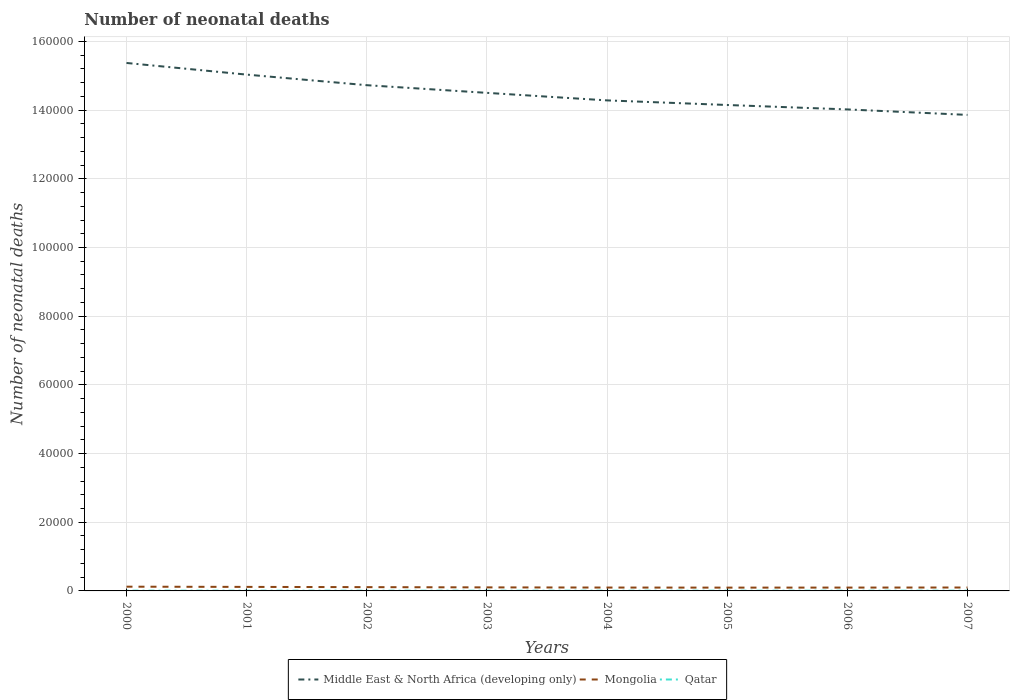How many different coloured lines are there?
Ensure brevity in your answer.  3. Does the line corresponding to Mongolia intersect with the line corresponding to Middle East & North Africa (developing only)?
Provide a succinct answer. No. Is the number of lines equal to the number of legend labels?
Your response must be concise. Yes. Across all years, what is the maximum number of neonatal deaths in in Mongolia?
Ensure brevity in your answer.  962. In which year was the number of neonatal deaths in in Qatar maximum?
Give a very brief answer. 2003. What is the total number of neonatal deaths in in Middle East & North Africa (developing only) in the graph?
Keep it short and to the point. 5764. What is the difference between the highest and the second highest number of neonatal deaths in in Qatar?
Provide a short and direct response. 11. What is the difference between the highest and the lowest number of neonatal deaths in in Qatar?
Keep it short and to the point. 2. Is the number of neonatal deaths in in Qatar strictly greater than the number of neonatal deaths in in Mongolia over the years?
Offer a very short reply. Yes. How many lines are there?
Give a very brief answer. 3. How many years are there in the graph?
Provide a short and direct response. 8. What is the difference between two consecutive major ticks on the Y-axis?
Your answer should be compact. 2.00e+04. Does the graph contain any zero values?
Provide a short and direct response. No. Does the graph contain grids?
Keep it short and to the point. Yes. Where does the legend appear in the graph?
Your response must be concise. Bottom center. How many legend labels are there?
Give a very brief answer. 3. What is the title of the graph?
Your answer should be compact. Number of neonatal deaths. Does "Kosovo" appear as one of the legend labels in the graph?
Give a very brief answer. No. What is the label or title of the X-axis?
Ensure brevity in your answer.  Years. What is the label or title of the Y-axis?
Your response must be concise. Number of neonatal deaths. What is the Number of neonatal deaths in Middle East & North Africa (developing only) in 2000?
Provide a short and direct response. 1.54e+05. What is the Number of neonatal deaths in Mongolia in 2000?
Your answer should be very brief. 1234. What is the Number of neonatal deaths of Middle East & North Africa (developing only) in 2001?
Offer a very short reply. 1.50e+05. What is the Number of neonatal deaths in Mongolia in 2001?
Your answer should be compact. 1172. What is the Number of neonatal deaths in Qatar in 2001?
Offer a terse response. 73. What is the Number of neonatal deaths in Middle East & North Africa (developing only) in 2002?
Offer a terse response. 1.47e+05. What is the Number of neonatal deaths of Mongolia in 2002?
Offer a very short reply. 1103. What is the Number of neonatal deaths in Qatar in 2002?
Provide a succinct answer. 70. What is the Number of neonatal deaths in Middle East & North Africa (developing only) in 2003?
Ensure brevity in your answer.  1.45e+05. What is the Number of neonatal deaths in Mongolia in 2003?
Keep it short and to the point. 1032. What is the Number of neonatal deaths in Middle East & North Africa (developing only) in 2004?
Provide a succinct answer. 1.43e+05. What is the Number of neonatal deaths of Mongolia in 2004?
Your answer should be compact. 984. What is the Number of neonatal deaths of Qatar in 2004?
Keep it short and to the point. 67. What is the Number of neonatal deaths of Middle East & North Africa (developing only) in 2005?
Your response must be concise. 1.41e+05. What is the Number of neonatal deaths in Mongolia in 2005?
Your response must be concise. 962. What is the Number of neonatal deaths of Qatar in 2005?
Your answer should be compact. 70. What is the Number of neonatal deaths in Middle East & North Africa (developing only) in 2006?
Provide a short and direct response. 1.40e+05. What is the Number of neonatal deaths in Mongolia in 2006?
Offer a terse response. 974. What is the Number of neonatal deaths of Middle East & North Africa (developing only) in 2007?
Make the answer very short. 1.39e+05. What is the Number of neonatal deaths of Mongolia in 2007?
Offer a very short reply. 995. What is the Number of neonatal deaths of Qatar in 2007?
Provide a succinct answer. 69. Across all years, what is the maximum Number of neonatal deaths in Middle East & North Africa (developing only)?
Your answer should be compact. 1.54e+05. Across all years, what is the maximum Number of neonatal deaths of Mongolia?
Your response must be concise. 1234. Across all years, what is the maximum Number of neonatal deaths of Qatar?
Provide a succinct answer. 78. Across all years, what is the minimum Number of neonatal deaths of Middle East & North Africa (developing only)?
Your answer should be compact. 1.39e+05. Across all years, what is the minimum Number of neonatal deaths of Mongolia?
Provide a short and direct response. 962. What is the total Number of neonatal deaths of Middle East & North Africa (developing only) in the graph?
Your answer should be very brief. 1.16e+06. What is the total Number of neonatal deaths of Mongolia in the graph?
Provide a succinct answer. 8456. What is the total Number of neonatal deaths of Qatar in the graph?
Provide a short and direct response. 562. What is the difference between the Number of neonatal deaths of Middle East & North Africa (developing only) in 2000 and that in 2001?
Offer a terse response. 3390. What is the difference between the Number of neonatal deaths in Mongolia in 2000 and that in 2001?
Make the answer very short. 62. What is the difference between the Number of neonatal deaths of Qatar in 2000 and that in 2001?
Your answer should be very brief. 5. What is the difference between the Number of neonatal deaths in Middle East & North Africa (developing only) in 2000 and that in 2002?
Make the answer very short. 6473. What is the difference between the Number of neonatal deaths in Mongolia in 2000 and that in 2002?
Your answer should be very brief. 131. What is the difference between the Number of neonatal deaths of Qatar in 2000 and that in 2002?
Make the answer very short. 8. What is the difference between the Number of neonatal deaths of Middle East & North Africa (developing only) in 2000 and that in 2003?
Offer a very short reply. 8705. What is the difference between the Number of neonatal deaths in Mongolia in 2000 and that in 2003?
Your response must be concise. 202. What is the difference between the Number of neonatal deaths of Qatar in 2000 and that in 2003?
Your answer should be very brief. 11. What is the difference between the Number of neonatal deaths of Middle East & North Africa (developing only) in 2000 and that in 2004?
Keep it short and to the point. 1.09e+04. What is the difference between the Number of neonatal deaths of Mongolia in 2000 and that in 2004?
Make the answer very short. 250. What is the difference between the Number of neonatal deaths of Middle East & North Africa (developing only) in 2000 and that in 2005?
Your response must be concise. 1.22e+04. What is the difference between the Number of neonatal deaths in Mongolia in 2000 and that in 2005?
Your answer should be compact. 272. What is the difference between the Number of neonatal deaths of Qatar in 2000 and that in 2005?
Make the answer very short. 8. What is the difference between the Number of neonatal deaths of Middle East & North Africa (developing only) in 2000 and that in 2006?
Your answer should be compact. 1.35e+04. What is the difference between the Number of neonatal deaths of Mongolia in 2000 and that in 2006?
Offer a terse response. 260. What is the difference between the Number of neonatal deaths of Middle East & North Africa (developing only) in 2000 and that in 2007?
Your answer should be very brief. 1.51e+04. What is the difference between the Number of neonatal deaths of Mongolia in 2000 and that in 2007?
Provide a succinct answer. 239. What is the difference between the Number of neonatal deaths of Middle East & North Africa (developing only) in 2001 and that in 2002?
Provide a short and direct response. 3083. What is the difference between the Number of neonatal deaths of Mongolia in 2001 and that in 2002?
Your answer should be very brief. 69. What is the difference between the Number of neonatal deaths in Middle East & North Africa (developing only) in 2001 and that in 2003?
Offer a terse response. 5315. What is the difference between the Number of neonatal deaths of Mongolia in 2001 and that in 2003?
Offer a terse response. 140. What is the difference between the Number of neonatal deaths of Qatar in 2001 and that in 2003?
Provide a short and direct response. 6. What is the difference between the Number of neonatal deaths of Middle East & North Africa (developing only) in 2001 and that in 2004?
Your answer should be compact. 7510. What is the difference between the Number of neonatal deaths of Mongolia in 2001 and that in 2004?
Provide a succinct answer. 188. What is the difference between the Number of neonatal deaths of Middle East & North Africa (developing only) in 2001 and that in 2005?
Your answer should be very brief. 8847. What is the difference between the Number of neonatal deaths in Mongolia in 2001 and that in 2005?
Provide a short and direct response. 210. What is the difference between the Number of neonatal deaths in Qatar in 2001 and that in 2005?
Offer a very short reply. 3. What is the difference between the Number of neonatal deaths in Middle East & North Africa (developing only) in 2001 and that in 2006?
Provide a short and direct response. 1.01e+04. What is the difference between the Number of neonatal deaths of Mongolia in 2001 and that in 2006?
Offer a terse response. 198. What is the difference between the Number of neonatal deaths in Qatar in 2001 and that in 2006?
Make the answer very short. 5. What is the difference between the Number of neonatal deaths in Middle East & North Africa (developing only) in 2001 and that in 2007?
Make the answer very short. 1.17e+04. What is the difference between the Number of neonatal deaths in Mongolia in 2001 and that in 2007?
Keep it short and to the point. 177. What is the difference between the Number of neonatal deaths of Qatar in 2001 and that in 2007?
Give a very brief answer. 4. What is the difference between the Number of neonatal deaths of Middle East & North Africa (developing only) in 2002 and that in 2003?
Offer a very short reply. 2232. What is the difference between the Number of neonatal deaths in Mongolia in 2002 and that in 2003?
Give a very brief answer. 71. What is the difference between the Number of neonatal deaths of Middle East & North Africa (developing only) in 2002 and that in 2004?
Give a very brief answer. 4427. What is the difference between the Number of neonatal deaths of Mongolia in 2002 and that in 2004?
Ensure brevity in your answer.  119. What is the difference between the Number of neonatal deaths of Middle East & North Africa (developing only) in 2002 and that in 2005?
Offer a very short reply. 5764. What is the difference between the Number of neonatal deaths of Mongolia in 2002 and that in 2005?
Offer a very short reply. 141. What is the difference between the Number of neonatal deaths in Qatar in 2002 and that in 2005?
Offer a terse response. 0. What is the difference between the Number of neonatal deaths of Middle East & North Africa (developing only) in 2002 and that in 2006?
Your response must be concise. 7053. What is the difference between the Number of neonatal deaths of Mongolia in 2002 and that in 2006?
Your answer should be compact. 129. What is the difference between the Number of neonatal deaths of Middle East & North Africa (developing only) in 2002 and that in 2007?
Give a very brief answer. 8648. What is the difference between the Number of neonatal deaths of Mongolia in 2002 and that in 2007?
Ensure brevity in your answer.  108. What is the difference between the Number of neonatal deaths in Qatar in 2002 and that in 2007?
Make the answer very short. 1. What is the difference between the Number of neonatal deaths in Middle East & North Africa (developing only) in 2003 and that in 2004?
Make the answer very short. 2195. What is the difference between the Number of neonatal deaths in Mongolia in 2003 and that in 2004?
Offer a very short reply. 48. What is the difference between the Number of neonatal deaths of Middle East & North Africa (developing only) in 2003 and that in 2005?
Provide a succinct answer. 3532. What is the difference between the Number of neonatal deaths of Mongolia in 2003 and that in 2005?
Your response must be concise. 70. What is the difference between the Number of neonatal deaths in Qatar in 2003 and that in 2005?
Your answer should be very brief. -3. What is the difference between the Number of neonatal deaths in Middle East & North Africa (developing only) in 2003 and that in 2006?
Ensure brevity in your answer.  4821. What is the difference between the Number of neonatal deaths of Qatar in 2003 and that in 2006?
Provide a short and direct response. -1. What is the difference between the Number of neonatal deaths in Middle East & North Africa (developing only) in 2003 and that in 2007?
Your answer should be compact. 6416. What is the difference between the Number of neonatal deaths in Qatar in 2003 and that in 2007?
Give a very brief answer. -2. What is the difference between the Number of neonatal deaths in Middle East & North Africa (developing only) in 2004 and that in 2005?
Provide a short and direct response. 1337. What is the difference between the Number of neonatal deaths of Mongolia in 2004 and that in 2005?
Your answer should be compact. 22. What is the difference between the Number of neonatal deaths of Middle East & North Africa (developing only) in 2004 and that in 2006?
Your answer should be compact. 2626. What is the difference between the Number of neonatal deaths of Qatar in 2004 and that in 2006?
Ensure brevity in your answer.  -1. What is the difference between the Number of neonatal deaths of Middle East & North Africa (developing only) in 2004 and that in 2007?
Offer a very short reply. 4221. What is the difference between the Number of neonatal deaths in Middle East & North Africa (developing only) in 2005 and that in 2006?
Provide a succinct answer. 1289. What is the difference between the Number of neonatal deaths in Qatar in 2005 and that in 2006?
Give a very brief answer. 2. What is the difference between the Number of neonatal deaths of Middle East & North Africa (developing only) in 2005 and that in 2007?
Offer a very short reply. 2884. What is the difference between the Number of neonatal deaths in Mongolia in 2005 and that in 2007?
Your answer should be very brief. -33. What is the difference between the Number of neonatal deaths of Middle East & North Africa (developing only) in 2006 and that in 2007?
Offer a very short reply. 1595. What is the difference between the Number of neonatal deaths of Qatar in 2006 and that in 2007?
Your response must be concise. -1. What is the difference between the Number of neonatal deaths of Middle East & North Africa (developing only) in 2000 and the Number of neonatal deaths of Mongolia in 2001?
Your answer should be compact. 1.53e+05. What is the difference between the Number of neonatal deaths of Middle East & North Africa (developing only) in 2000 and the Number of neonatal deaths of Qatar in 2001?
Give a very brief answer. 1.54e+05. What is the difference between the Number of neonatal deaths in Mongolia in 2000 and the Number of neonatal deaths in Qatar in 2001?
Give a very brief answer. 1161. What is the difference between the Number of neonatal deaths in Middle East & North Africa (developing only) in 2000 and the Number of neonatal deaths in Mongolia in 2002?
Offer a terse response. 1.53e+05. What is the difference between the Number of neonatal deaths of Middle East & North Africa (developing only) in 2000 and the Number of neonatal deaths of Qatar in 2002?
Your response must be concise. 1.54e+05. What is the difference between the Number of neonatal deaths in Mongolia in 2000 and the Number of neonatal deaths in Qatar in 2002?
Keep it short and to the point. 1164. What is the difference between the Number of neonatal deaths in Middle East & North Africa (developing only) in 2000 and the Number of neonatal deaths in Mongolia in 2003?
Ensure brevity in your answer.  1.53e+05. What is the difference between the Number of neonatal deaths in Middle East & North Africa (developing only) in 2000 and the Number of neonatal deaths in Qatar in 2003?
Provide a succinct answer. 1.54e+05. What is the difference between the Number of neonatal deaths in Mongolia in 2000 and the Number of neonatal deaths in Qatar in 2003?
Provide a short and direct response. 1167. What is the difference between the Number of neonatal deaths of Middle East & North Africa (developing only) in 2000 and the Number of neonatal deaths of Mongolia in 2004?
Provide a short and direct response. 1.53e+05. What is the difference between the Number of neonatal deaths of Middle East & North Africa (developing only) in 2000 and the Number of neonatal deaths of Qatar in 2004?
Provide a succinct answer. 1.54e+05. What is the difference between the Number of neonatal deaths of Mongolia in 2000 and the Number of neonatal deaths of Qatar in 2004?
Offer a very short reply. 1167. What is the difference between the Number of neonatal deaths in Middle East & North Africa (developing only) in 2000 and the Number of neonatal deaths in Mongolia in 2005?
Your answer should be compact. 1.53e+05. What is the difference between the Number of neonatal deaths in Middle East & North Africa (developing only) in 2000 and the Number of neonatal deaths in Qatar in 2005?
Keep it short and to the point. 1.54e+05. What is the difference between the Number of neonatal deaths in Mongolia in 2000 and the Number of neonatal deaths in Qatar in 2005?
Give a very brief answer. 1164. What is the difference between the Number of neonatal deaths in Middle East & North Africa (developing only) in 2000 and the Number of neonatal deaths in Mongolia in 2006?
Your response must be concise. 1.53e+05. What is the difference between the Number of neonatal deaths in Middle East & North Africa (developing only) in 2000 and the Number of neonatal deaths in Qatar in 2006?
Provide a short and direct response. 1.54e+05. What is the difference between the Number of neonatal deaths of Mongolia in 2000 and the Number of neonatal deaths of Qatar in 2006?
Offer a very short reply. 1166. What is the difference between the Number of neonatal deaths in Middle East & North Africa (developing only) in 2000 and the Number of neonatal deaths in Mongolia in 2007?
Give a very brief answer. 1.53e+05. What is the difference between the Number of neonatal deaths of Middle East & North Africa (developing only) in 2000 and the Number of neonatal deaths of Qatar in 2007?
Keep it short and to the point. 1.54e+05. What is the difference between the Number of neonatal deaths of Mongolia in 2000 and the Number of neonatal deaths of Qatar in 2007?
Keep it short and to the point. 1165. What is the difference between the Number of neonatal deaths of Middle East & North Africa (developing only) in 2001 and the Number of neonatal deaths of Mongolia in 2002?
Keep it short and to the point. 1.49e+05. What is the difference between the Number of neonatal deaths in Middle East & North Africa (developing only) in 2001 and the Number of neonatal deaths in Qatar in 2002?
Ensure brevity in your answer.  1.50e+05. What is the difference between the Number of neonatal deaths of Mongolia in 2001 and the Number of neonatal deaths of Qatar in 2002?
Offer a very short reply. 1102. What is the difference between the Number of neonatal deaths of Middle East & North Africa (developing only) in 2001 and the Number of neonatal deaths of Mongolia in 2003?
Provide a succinct answer. 1.49e+05. What is the difference between the Number of neonatal deaths of Middle East & North Africa (developing only) in 2001 and the Number of neonatal deaths of Qatar in 2003?
Your answer should be compact. 1.50e+05. What is the difference between the Number of neonatal deaths in Mongolia in 2001 and the Number of neonatal deaths in Qatar in 2003?
Make the answer very short. 1105. What is the difference between the Number of neonatal deaths of Middle East & North Africa (developing only) in 2001 and the Number of neonatal deaths of Mongolia in 2004?
Provide a succinct answer. 1.49e+05. What is the difference between the Number of neonatal deaths of Middle East & North Africa (developing only) in 2001 and the Number of neonatal deaths of Qatar in 2004?
Offer a terse response. 1.50e+05. What is the difference between the Number of neonatal deaths of Mongolia in 2001 and the Number of neonatal deaths of Qatar in 2004?
Provide a succinct answer. 1105. What is the difference between the Number of neonatal deaths of Middle East & North Africa (developing only) in 2001 and the Number of neonatal deaths of Mongolia in 2005?
Keep it short and to the point. 1.49e+05. What is the difference between the Number of neonatal deaths of Middle East & North Africa (developing only) in 2001 and the Number of neonatal deaths of Qatar in 2005?
Give a very brief answer. 1.50e+05. What is the difference between the Number of neonatal deaths in Mongolia in 2001 and the Number of neonatal deaths in Qatar in 2005?
Give a very brief answer. 1102. What is the difference between the Number of neonatal deaths in Middle East & North Africa (developing only) in 2001 and the Number of neonatal deaths in Mongolia in 2006?
Provide a short and direct response. 1.49e+05. What is the difference between the Number of neonatal deaths of Middle East & North Africa (developing only) in 2001 and the Number of neonatal deaths of Qatar in 2006?
Provide a succinct answer. 1.50e+05. What is the difference between the Number of neonatal deaths of Mongolia in 2001 and the Number of neonatal deaths of Qatar in 2006?
Your answer should be compact. 1104. What is the difference between the Number of neonatal deaths of Middle East & North Africa (developing only) in 2001 and the Number of neonatal deaths of Mongolia in 2007?
Make the answer very short. 1.49e+05. What is the difference between the Number of neonatal deaths in Middle East & North Africa (developing only) in 2001 and the Number of neonatal deaths in Qatar in 2007?
Your answer should be compact. 1.50e+05. What is the difference between the Number of neonatal deaths in Mongolia in 2001 and the Number of neonatal deaths in Qatar in 2007?
Your answer should be compact. 1103. What is the difference between the Number of neonatal deaths of Middle East & North Africa (developing only) in 2002 and the Number of neonatal deaths of Mongolia in 2003?
Provide a short and direct response. 1.46e+05. What is the difference between the Number of neonatal deaths of Middle East & North Africa (developing only) in 2002 and the Number of neonatal deaths of Qatar in 2003?
Ensure brevity in your answer.  1.47e+05. What is the difference between the Number of neonatal deaths of Mongolia in 2002 and the Number of neonatal deaths of Qatar in 2003?
Ensure brevity in your answer.  1036. What is the difference between the Number of neonatal deaths of Middle East & North Africa (developing only) in 2002 and the Number of neonatal deaths of Mongolia in 2004?
Your response must be concise. 1.46e+05. What is the difference between the Number of neonatal deaths of Middle East & North Africa (developing only) in 2002 and the Number of neonatal deaths of Qatar in 2004?
Offer a very short reply. 1.47e+05. What is the difference between the Number of neonatal deaths of Mongolia in 2002 and the Number of neonatal deaths of Qatar in 2004?
Ensure brevity in your answer.  1036. What is the difference between the Number of neonatal deaths in Middle East & North Africa (developing only) in 2002 and the Number of neonatal deaths in Mongolia in 2005?
Make the answer very short. 1.46e+05. What is the difference between the Number of neonatal deaths in Middle East & North Africa (developing only) in 2002 and the Number of neonatal deaths in Qatar in 2005?
Give a very brief answer. 1.47e+05. What is the difference between the Number of neonatal deaths in Mongolia in 2002 and the Number of neonatal deaths in Qatar in 2005?
Offer a terse response. 1033. What is the difference between the Number of neonatal deaths of Middle East & North Africa (developing only) in 2002 and the Number of neonatal deaths of Mongolia in 2006?
Your response must be concise. 1.46e+05. What is the difference between the Number of neonatal deaths in Middle East & North Africa (developing only) in 2002 and the Number of neonatal deaths in Qatar in 2006?
Offer a very short reply. 1.47e+05. What is the difference between the Number of neonatal deaths in Mongolia in 2002 and the Number of neonatal deaths in Qatar in 2006?
Make the answer very short. 1035. What is the difference between the Number of neonatal deaths in Middle East & North Africa (developing only) in 2002 and the Number of neonatal deaths in Mongolia in 2007?
Your answer should be very brief. 1.46e+05. What is the difference between the Number of neonatal deaths of Middle East & North Africa (developing only) in 2002 and the Number of neonatal deaths of Qatar in 2007?
Provide a short and direct response. 1.47e+05. What is the difference between the Number of neonatal deaths in Mongolia in 2002 and the Number of neonatal deaths in Qatar in 2007?
Offer a very short reply. 1034. What is the difference between the Number of neonatal deaths in Middle East & North Africa (developing only) in 2003 and the Number of neonatal deaths in Mongolia in 2004?
Your response must be concise. 1.44e+05. What is the difference between the Number of neonatal deaths of Middle East & North Africa (developing only) in 2003 and the Number of neonatal deaths of Qatar in 2004?
Provide a succinct answer. 1.45e+05. What is the difference between the Number of neonatal deaths in Mongolia in 2003 and the Number of neonatal deaths in Qatar in 2004?
Your response must be concise. 965. What is the difference between the Number of neonatal deaths in Middle East & North Africa (developing only) in 2003 and the Number of neonatal deaths in Mongolia in 2005?
Your answer should be compact. 1.44e+05. What is the difference between the Number of neonatal deaths of Middle East & North Africa (developing only) in 2003 and the Number of neonatal deaths of Qatar in 2005?
Make the answer very short. 1.45e+05. What is the difference between the Number of neonatal deaths in Mongolia in 2003 and the Number of neonatal deaths in Qatar in 2005?
Provide a succinct answer. 962. What is the difference between the Number of neonatal deaths in Middle East & North Africa (developing only) in 2003 and the Number of neonatal deaths in Mongolia in 2006?
Keep it short and to the point. 1.44e+05. What is the difference between the Number of neonatal deaths of Middle East & North Africa (developing only) in 2003 and the Number of neonatal deaths of Qatar in 2006?
Offer a terse response. 1.45e+05. What is the difference between the Number of neonatal deaths of Mongolia in 2003 and the Number of neonatal deaths of Qatar in 2006?
Provide a short and direct response. 964. What is the difference between the Number of neonatal deaths in Middle East & North Africa (developing only) in 2003 and the Number of neonatal deaths in Mongolia in 2007?
Offer a terse response. 1.44e+05. What is the difference between the Number of neonatal deaths of Middle East & North Africa (developing only) in 2003 and the Number of neonatal deaths of Qatar in 2007?
Give a very brief answer. 1.45e+05. What is the difference between the Number of neonatal deaths of Mongolia in 2003 and the Number of neonatal deaths of Qatar in 2007?
Provide a short and direct response. 963. What is the difference between the Number of neonatal deaths in Middle East & North Africa (developing only) in 2004 and the Number of neonatal deaths in Mongolia in 2005?
Make the answer very short. 1.42e+05. What is the difference between the Number of neonatal deaths in Middle East & North Africa (developing only) in 2004 and the Number of neonatal deaths in Qatar in 2005?
Provide a short and direct response. 1.43e+05. What is the difference between the Number of neonatal deaths in Mongolia in 2004 and the Number of neonatal deaths in Qatar in 2005?
Your answer should be compact. 914. What is the difference between the Number of neonatal deaths of Middle East & North Africa (developing only) in 2004 and the Number of neonatal deaths of Mongolia in 2006?
Your answer should be compact. 1.42e+05. What is the difference between the Number of neonatal deaths of Middle East & North Africa (developing only) in 2004 and the Number of neonatal deaths of Qatar in 2006?
Offer a terse response. 1.43e+05. What is the difference between the Number of neonatal deaths of Mongolia in 2004 and the Number of neonatal deaths of Qatar in 2006?
Your answer should be compact. 916. What is the difference between the Number of neonatal deaths of Middle East & North Africa (developing only) in 2004 and the Number of neonatal deaths of Mongolia in 2007?
Ensure brevity in your answer.  1.42e+05. What is the difference between the Number of neonatal deaths in Middle East & North Africa (developing only) in 2004 and the Number of neonatal deaths in Qatar in 2007?
Give a very brief answer. 1.43e+05. What is the difference between the Number of neonatal deaths of Mongolia in 2004 and the Number of neonatal deaths of Qatar in 2007?
Offer a terse response. 915. What is the difference between the Number of neonatal deaths of Middle East & North Africa (developing only) in 2005 and the Number of neonatal deaths of Mongolia in 2006?
Provide a succinct answer. 1.41e+05. What is the difference between the Number of neonatal deaths of Middle East & North Africa (developing only) in 2005 and the Number of neonatal deaths of Qatar in 2006?
Give a very brief answer. 1.41e+05. What is the difference between the Number of neonatal deaths of Mongolia in 2005 and the Number of neonatal deaths of Qatar in 2006?
Make the answer very short. 894. What is the difference between the Number of neonatal deaths in Middle East & North Africa (developing only) in 2005 and the Number of neonatal deaths in Mongolia in 2007?
Provide a succinct answer. 1.40e+05. What is the difference between the Number of neonatal deaths in Middle East & North Africa (developing only) in 2005 and the Number of neonatal deaths in Qatar in 2007?
Keep it short and to the point. 1.41e+05. What is the difference between the Number of neonatal deaths of Mongolia in 2005 and the Number of neonatal deaths of Qatar in 2007?
Your answer should be compact. 893. What is the difference between the Number of neonatal deaths of Middle East & North Africa (developing only) in 2006 and the Number of neonatal deaths of Mongolia in 2007?
Your response must be concise. 1.39e+05. What is the difference between the Number of neonatal deaths in Middle East & North Africa (developing only) in 2006 and the Number of neonatal deaths in Qatar in 2007?
Your response must be concise. 1.40e+05. What is the difference between the Number of neonatal deaths in Mongolia in 2006 and the Number of neonatal deaths in Qatar in 2007?
Provide a short and direct response. 905. What is the average Number of neonatal deaths of Middle East & North Africa (developing only) per year?
Your response must be concise. 1.45e+05. What is the average Number of neonatal deaths in Mongolia per year?
Provide a short and direct response. 1057. What is the average Number of neonatal deaths in Qatar per year?
Offer a terse response. 70.25. In the year 2000, what is the difference between the Number of neonatal deaths of Middle East & North Africa (developing only) and Number of neonatal deaths of Mongolia?
Give a very brief answer. 1.52e+05. In the year 2000, what is the difference between the Number of neonatal deaths in Middle East & North Africa (developing only) and Number of neonatal deaths in Qatar?
Give a very brief answer. 1.54e+05. In the year 2000, what is the difference between the Number of neonatal deaths in Mongolia and Number of neonatal deaths in Qatar?
Provide a short and direct response. 1156. In the year 2001, what is the difference between the Number of neonatal deaths in Middle East & North Africa (developing only) and Number of neonatal deaths in Mongolia?
Offer a very short reply. 1.49e+05. In the year 2001, what is the difference between the Number of neonatal deaths in Middle East & North Africa (developing only) and Number of neonatal deaths in Qatar?
Offer a terse response. 1.50e+05. In the year 2001, what is the difference between the Number of neonatal deaths in Mongolia and Number of neonatal deaths in Qatar?
Your answer should be compact. 1099. In the year 2002, what is the difference between the Number of neonatal deaths of Middle East & North Africa (developing only) and Number of neonatal deaths of Mongolia?
Make the answer very short. 1.46e+05. In the year 2002, what is the difference between the Number of neonatal deaths in Middle East & North Africa (developing only) and Number of neonatal deaths in Qatar?
Provide a succinct answer. 1.47e+05. In the year 2002, what is the difference between the Number of neonatal deaths of Mongolia and Number of neonatal deaths of Qatar?
Your answer should be compact. 1033. In the year 2003, what is the difference between the Number of neonatal deaths of Middle East & North Africa (developing only) and Number of neonatal deaths of Mongolia?
Your answer should be very brief. 1.44e+05. In the year 2003, what is the difference between the Number of neonatal deaths in Middle East & North Africa (developing only) and Number of neonatal deaths in Qatar?
Ensure brevity in your answer.  1.45e+05. In the year 2003, what is the difference between the Number of neonatal deaths in Mongolia and Number of neonatal deaths in Qatar?
Ensure brevity in your answer.  965. In the year 2004, what is the difference between the Number of neonatal deaths in Middle East & North Africa (developing only) and Number of neonatal deaths in Mongolia?
Your answer should be very brief. 1.42e+05. In the year 2004, what is the difference between the Number of neonatal deaths of Middle East & North Africa (developing only) and Number of neonatal deaths of Qatar?
Provide a short and direct response. 1.43e+05. In the year 2004, what is the difference between the Number of neonatal deaths in Mongolia and Number of neonatal deaths in Qatar?
Your answer should be compact. 917. In the year 2005, what is the difference between the Number of neonatal deaths of Middle East & North Africa (developing only) and Number of neonatal deaths of Mongolia?
Offer a terse response. 1.41e+05. In the year 2005, what is the difference between the Number of neonatal deaths of Middle East & North Africa (developing only) and Number of neonatal deaths of Qatar?
Your answer should be very brief. 1.41e+05. In the year 2005, what is the difference between the Number of neonatal deaths in Mongolia and Number of neonatal deaths in Qatar?
Offer a terse response. 892. In the year 2006, what is the difference between the Number of neonatal deaths in Middle East & North Africa (developing only) and Number of neonatal deaths in Mongolia?
Your response must be concise. 1.39e+05. In the year 2006, what is the difference between the Number of neonatal deaths of Middle East & North Africa (developing only) and Number of neonatal deaths of Qatar?
Offer a very short reply. 1.40e+05. In the year 2006, what is the difference between the Number of neonatal deaths of Mongolia and Number of neonatal deaths of Qatar?
Your answer should be very brief. 906. In the year 2007, what is the difference between the Number of neonatal deaths of Middle East & North Africa (developing only) and Number of neonatal deaths of Mongolia?
Offer a terse response. 1.38e+05. In the year 2007, what is the difference between the Number of neonatal deaths of Middle East & North Africa (developing only) and Number of neonatal deaths of Qatar?
Keep it short and to the point. 1.39e+05. In the year 2007, what is the difference between the Number of neonatal deaths of Mongolia and Number of neonatal deaths of Qatar?
Your answer should be very brief. 926. What is the ratio of the Number of neonatal deaths of Middle East & North Africa (developing only) in 2000 to that in 2001?
Give a very brief answer. 1.02. What is the ratio of the Number of neonatal deaths of Mongolia in 2000 to that in 2001?
Offer a terse response. 1.05. What is the ratio of the Number of neonatal deaths in Qatar in 2000 to that in 2001?
Give a very brief answer. 1.07. What is the ratio of the Number of neonatal deaths of Middle East & North Africa (developing only) in 2000 to that in 2002?
Offer a terse response. 1.04. What is the ratio of the Number of neonatal deaths of Mongolia in 2000 to that in 2002?
Offer a terse response. 1.12. What is the ratio of the Number of neonatal deaths in Qatar in 2000 to that in 2002?
Offer a terse response. 1.11. What is the ratio of the Number of neonatal deaths in Middle East & North Africa (developing only) in 2000 to that in 2003?
Offer a terse response. 1.06. What is the ratio of the Number of neonatal deaths of Mongolia in 2000 to that in 2003?
Your response must be concise. 1.2. What is the ratio of the Number of neonatal deaths in Qatar in 2000 to that in 2003?
Provide a succinct answer. 1.16. What is the ratio of the Number of neonatal deaths in Middle East & North Africa (developing only) in 2000 to that in 2004?
Your response must be concise. 1.08. What is the ratio of the Number of neonatal deaths of Mongolia in 2000 to that in 2004?
Make the answer very short. 1.25. What is the ratio of the Number of neonatal deaths in Qatar in 2000 to that in 2004?
Give a very brief answer. 1.16. What is the ratio of the Number of neonatal deaths of Middle East & North Africa (developing only) in 2000 to that in 2005?
Your answer should be compact. 1.09. What is the ratio of the Number of neonatal deaths of Mongolia in 2000 to that in 2005?
Your answer should be compact. 1.28. What is the ratio of the Number of neonatal deaths of Qatar in 2000 to that in 2005?
Keep it short and to the point. 1.11. What is the ratio of the Number of neonatal deaths of Middle East & North Africa (developing only) in 2000 to that in 2006?
Your answer should be very brief. 1.1. What is the ratio of the Number of neonatal deaths in Mongolia in 2000 to that in 2006?
Keep it short and to the point. 1.27. What is the ratio of the Number of neonatal deaths of Qatar in 2000 to that in 2006?
Your response must be concise. 1.15. What is the ratio of the Number of neonatal deaths in Middle East & North Africa (developing only) in 2000 to that in 2007?
Your answer should be compact. 1.11. What is the ratio of the Number of neonatal deaths of Mongolia in 2000 to that in 2007?
Ensure brevity in your answer.  1.24. What is the ratio of the Number of neonatal deaths in Qatar in 2000 to that in 2007?
Your answer should be compact. 1.13. What is the ratio of the Number of neonatal deaths of Middle East & North Africa (developing only) in 2001 to that in 2002?
Provide a short and direct response. 1.02. What is the ratio of the Number of neonatal deaths in Mongolia in 2001 to that in 2002?
Make the answer very short. 1.06. What is the ratio of the Number of neonatal deaths in Qatar in 2001 to that in 2002?
Offer a terse response. 1.04. What is the ratio of the Number of neonatal deaths of Middle East & North Africa (developing only) in 2001 to that in 2003?
Give a very brief answer. 1.04. What is the ratio of the Number of neonatal deaths in Mongolia in 2001 to that in 2003?
Provide a short and direct response. 1.14. What is the ratio of the Number of neonatal deaths in Qatar in 2001 to that in 2003?
Provide a short and direct response. 1.09. What is the ratio of the Number of neonatal deaths in Middle East & North Africa (developing only) in 2001 to that in 2004?
Give a very brief answer. 1.05. What is the ratio of the Number of neonatal deaths in Mongolia in 2001 to that in 2004?
Your answer should be compact. 1.19. What is the ratio of the Number of neonatal deaths in Qatar in 2001 to that in 2004?
Ensure brevity in your answer.  1.09. What is the ratio of the Number of neonatal deaths in Mongolia in 2001 to that in 2005?
Provide a short and direct response. 1.22. What is the ratio of the Number of neonatal deaths in Qatar in 2001 to that in 2005?
Provide a short and direct response. 1.04. What is the ratio of the Number of neonatal deaths of Middle East & North Africa (developing only) in 2001 to that in 2006?
Provide a short and direct response. 1.07. What is the ratio of the Number of neonatal deaths in Mongolia in 2001 to that in 2006?
Keep it short and to the point. 1.2. What is the ratio of the Number of neonatal deaths of Qatar in 2001 to that in 2006?
Offer a very short reply. 1.07. What is the ratio of the Number of neonatal deaths of Middle East & North Africa (developing only) in 2001 to that in 2007?
Make the answer very short. 1.08. What is the ratio of the Number of neonatal deaths of Mongolia in 2001 to that in 2007?
Provide a succinct answer. 1.18. What is the ratio of the Number of neonatal deaths of Qatar in 2001 to that in 2007?
Provide a succinct answer. 1.06. What is the ratio of the Number of neonatal deaths of Middle East & North Africa (developing only) in 2002 to that in 2003?
Provide a succinct answer. 1.02. What is the ratio of the Number of neonatal deaths of Mongolia in 2002 to that in 2003?
Give a very brief answer. 1.07. What is the ratio of the Number of neonatal deaths of Qatar in 2002 to that in 2003?
Offer a very short reply. 1.04. What is the ratio of the Number of neonatal deaths of Middle East & North Africa (developing only) in 2002 to that in 2004?
Offer a very short reply. 1.03. What is the ratio of the Number of neonatal deaths of Mongolia in 2002 to that in 2004?
Provide a short and direct response. 1.12. What is the ratio of the Number of neonatal deaths of Qatar in 2002 to that in 2004?
Provide a succinct answer. 1.04. What is the ratio of the Number of neonatal deaths in Middle East & North Africa (developing only) in 2002 to that in 2005?
Give a very brief answer. 1.04. What is the ratio of the Number of neonatal deaths in Mongolia in 2002 to that in 2005?
Keep it short and to the point. 1.15. What is the ratio of the Number of neonatal deaths of Qatar in 2002 to that in 2005?
Your answer should be very brief. 1. What is the ratio of the Number of neonatal deaths in Middle East & North Africa (developing only) in 2002 to that in 2006?
Give a very brief answer. 1.05. What is the ratio of the Number of neonatal deaths of Mongolia in 2002 to that in 2006?
Make the answer very short. 1.13. What is the ratio of the Number of neonatal deaths in Qatar in 2002 to that in 2006?
Provide a succinct answer. 1.03. What is the ratio of the Number of neonatal deaths of Middle East & North Africa (developing only) in 2002 to that in 2007?
Your response must be concise. 1.06. What is the ratio of the Number of neonatal deaths in Mongolia in 2002 to that in 2007?
Your answer should be very brief. 1.11. What is the ratio of the Number of neonatal deaths in Qatar in 2002 to that in 2007?
Provide a succinct answer. 1.01. What is the ratio of the Number of neonatal deaths in Middle East & North Africa (developing only) in 2003 to that in 2004?
Your response must be concise. 1.02. What is the ratio of the Number of neonatal deaths of Mongolia in 2003 to that in 2004?
Ensure brevity in your answer.  1.05. What is the ratio of the Number of neonatal deaths in Mongolia in 2003 to that in 2005?
Keep it short and to the point. 1.07. What is the ratio of the Number of neonatal deaths in Qatar in 2003 to that in 2005?
Ensure brevity in your answer.  0.96. What is the ratio of the Number of neonatal deaths in Middle East & North Africa (developing only) in 2003 to that in 2006?
Give a very brief answer. 1.03. What is the ratio of the Number of neonatal deaths in Mongolia in 2003 to that in 2006?
Your answer should be very brief. 1.06. What is the ratio of the Number of neonatal deaths in Middle East & North Africa (developing only) in 2003 to that in 2007?
Keep it short and to the point. 1.05. What is the ratio of the Number of neonatal deaths in Mongolia in 2003 to that in 2007?
Offer a terse response. 1.04. What is the ratio of the Number of neonatal deaths of Qatar in 2003 to that in 2007?
Provide a short and direct response. 0.97. What is the ratio of the Number of neonatal deaths in Middle East & North Africa (developing only) in 2004 to that in 2005?
Keep it short and to the point. 1.01. What is the ratio of the Number of neonatal deaths of Mongolia in 2004 to that in 2005?
Provide a short and direct response. 1.02. What is the ratio of the Number of neonatal deaths in Qatar in 2004 to that in 2005?
Make the answer very short. 0.96. What is the ratio of the Number of neonatal deaths of Middle East & North Africa (developing only) in 2004 to that in 2006?
Provide a succinct answer. 1.02. What is the ratio of the Number of neonatal deaths of Mongolia in 2004 to that in 2006?
Provide a short and direct response. 1.01. What is the ratio of the Number of neonatal deaths of Qatar in 2004 to that in 2006?
Your response must be concise. 0.99. What is the ratio of the Number of neonatal deaths of Middle East & North Africa (developing only) in 2004 to that in 2007?
Your answer should be very brief. 1.03. What is the ratio of the Number of neonatal deaths in Mongolia in 2004 to that in 2007?
Offer a very short reply. 0.99. What is the ratio of the Number of neonatal deaths in Qatar in 2004 to that in 2007?
Ensure brevity in your answer.  0.97. What is the ratio of the Number of neonatal deaths of Middle East & North Africa (developing only) in 2005 to that in 2006?
Your answer should be very brief. 1.01. What is the ratio of the Number of neonatal deaths of Qatar in 2005 to that in 2006?
Offer a terse response. 1.03. What is the ratio of the Number of neonatal deaths in Middle East & North Africa (developing only) in 2005 to that in 2007?
Ensure brevity in your answer.  1.02. What is the ratio of the Number of neonatal deaths of Mongolia in 2005 to that in 2007?
Make the answer very short. 0.97. What is the ratio of the Number of neonatal deaths of Qatar in 2005 to that in 2007?
Provide a short and direct response. 1.01. What is the ratio of the Number of neonatal deaths in Middle East & North Africa (developing only) in 2006 to that in 2007?
Offer a terse response. 1.01. What is the ratio of the Number of neonatal deaths in Mongolia in 2006 to that in 2007?
Provide a succinct answer. 0.98. What is the ratio of the Number of neonatal deaths of Qatar in 2006 to that in 2007?
Provide a short and direct response. 0.99. What is the difference between the highest and the second highest Number of neonatal deaths of Middle East & North Africa (developing only)?
Provide a short and direct response. 3390. What is the difference between the highest and the second highest Number of neonatal deaths of Mongolia?
Your response must be concise. 62. What is the difference between the highest and the lowest Number of neonatal deaths in Middle East & North Africa (developing only)?
Your answer should be very brief. 1.51e+04. What is the difference between the highest and the lowest Number of neonatal deaths of Mongolia?
Offer a terse response. 272. 